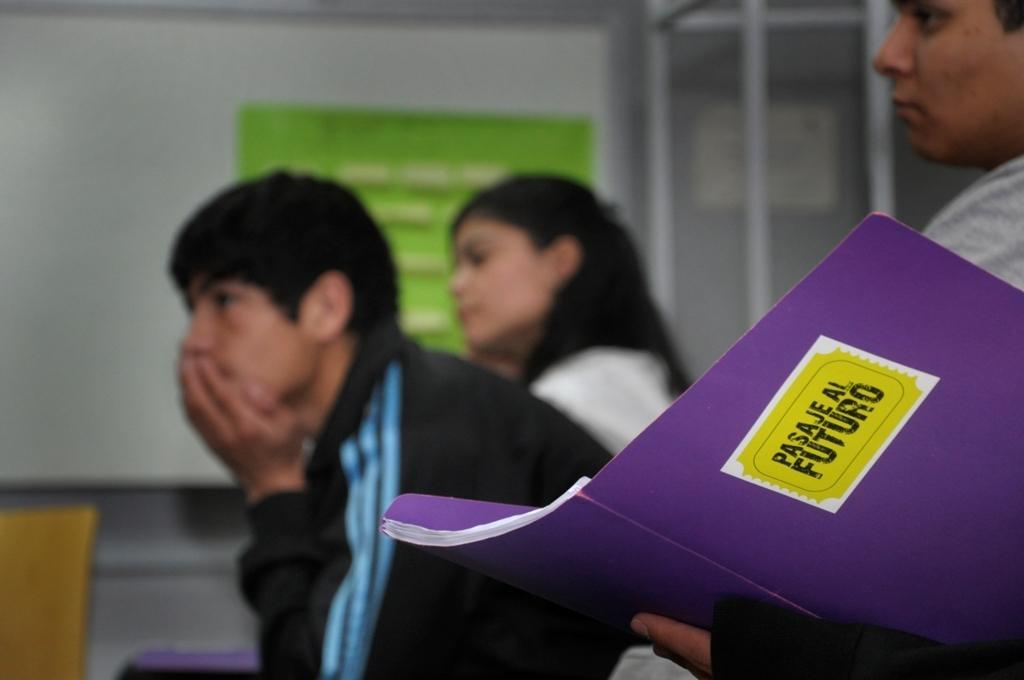Please provide a concise description of this image. In this image I can see group of people sitting, in front the person is holding a purple color book and the person is wearing black color jacket. Background I can see a banner in green color and the wall in white color. 